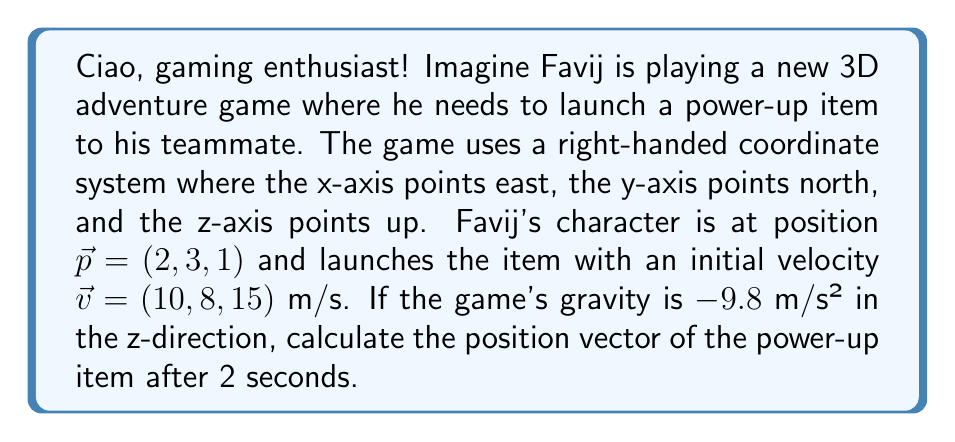Can you answer this question? Let's approach this step-by-step using vector operations:

1) The position of an object under constant acceleration is given by the equation:

   $$\vec{r}(t) = \vec{p} + \vec{v}t + \frac{1}{2}\vec{a}t^2$$

   Where $\vec{r}(t)$ is the position vector at time $t$, $\vec{p}$ is the initial position, $\vec{v}$ is the initial velocity, and $\vec{a}$ is the acceleration.

2) We know:
   - $\vec{p} = (2, 3, 1)$
   - $\vec{v} = (10, 8, 15)$
   - $\vec{a} = (0, 0, -9.8)$ (gravity only affects the z-component)
   - $t = 2$ seconds

3) Let's substitute these into our equation:

   $$\vec{r}(2) = (2, 3, 1) + (10, 8, 15)(2) + \frac{1}{2}(0, 0, -9.8)(2)^2$$

4) Simplify:
   $$\vec{r}(2) = (2, 3, 1) + (20, 16, 30) + (0, 0, -19.6)$$

5) Add the vectors:
   $$\vec{r}(2) = (2+20, 3+16, 1+30-19.6)$$

6) Compute the final result:
   $$\vec{r}(2) = (22, 19, 11.4)$$
Answer: The position vector of the power-up item after 2 seconds is $\vec{r}(2) = (22, 19, 11.4)$ meters. 